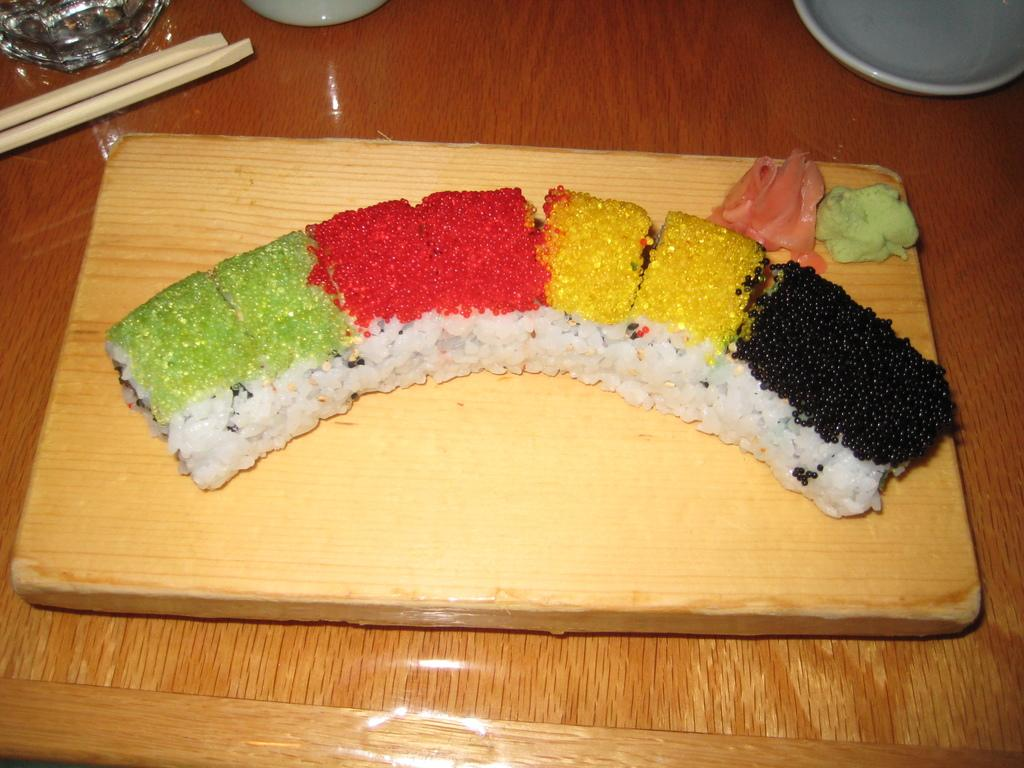What is the main object in the image? There is a wooden plank in the image. What is placed on the wooden plank? There are food items on the wooden plank, including rice. What utensils are present on the wooden plank? There are chopsticks on the wooden plank. What type of container is on the wooden plank? There is a bowl on the wooden plank. What type of railway is visible in the image? There is no railway present in the image. 